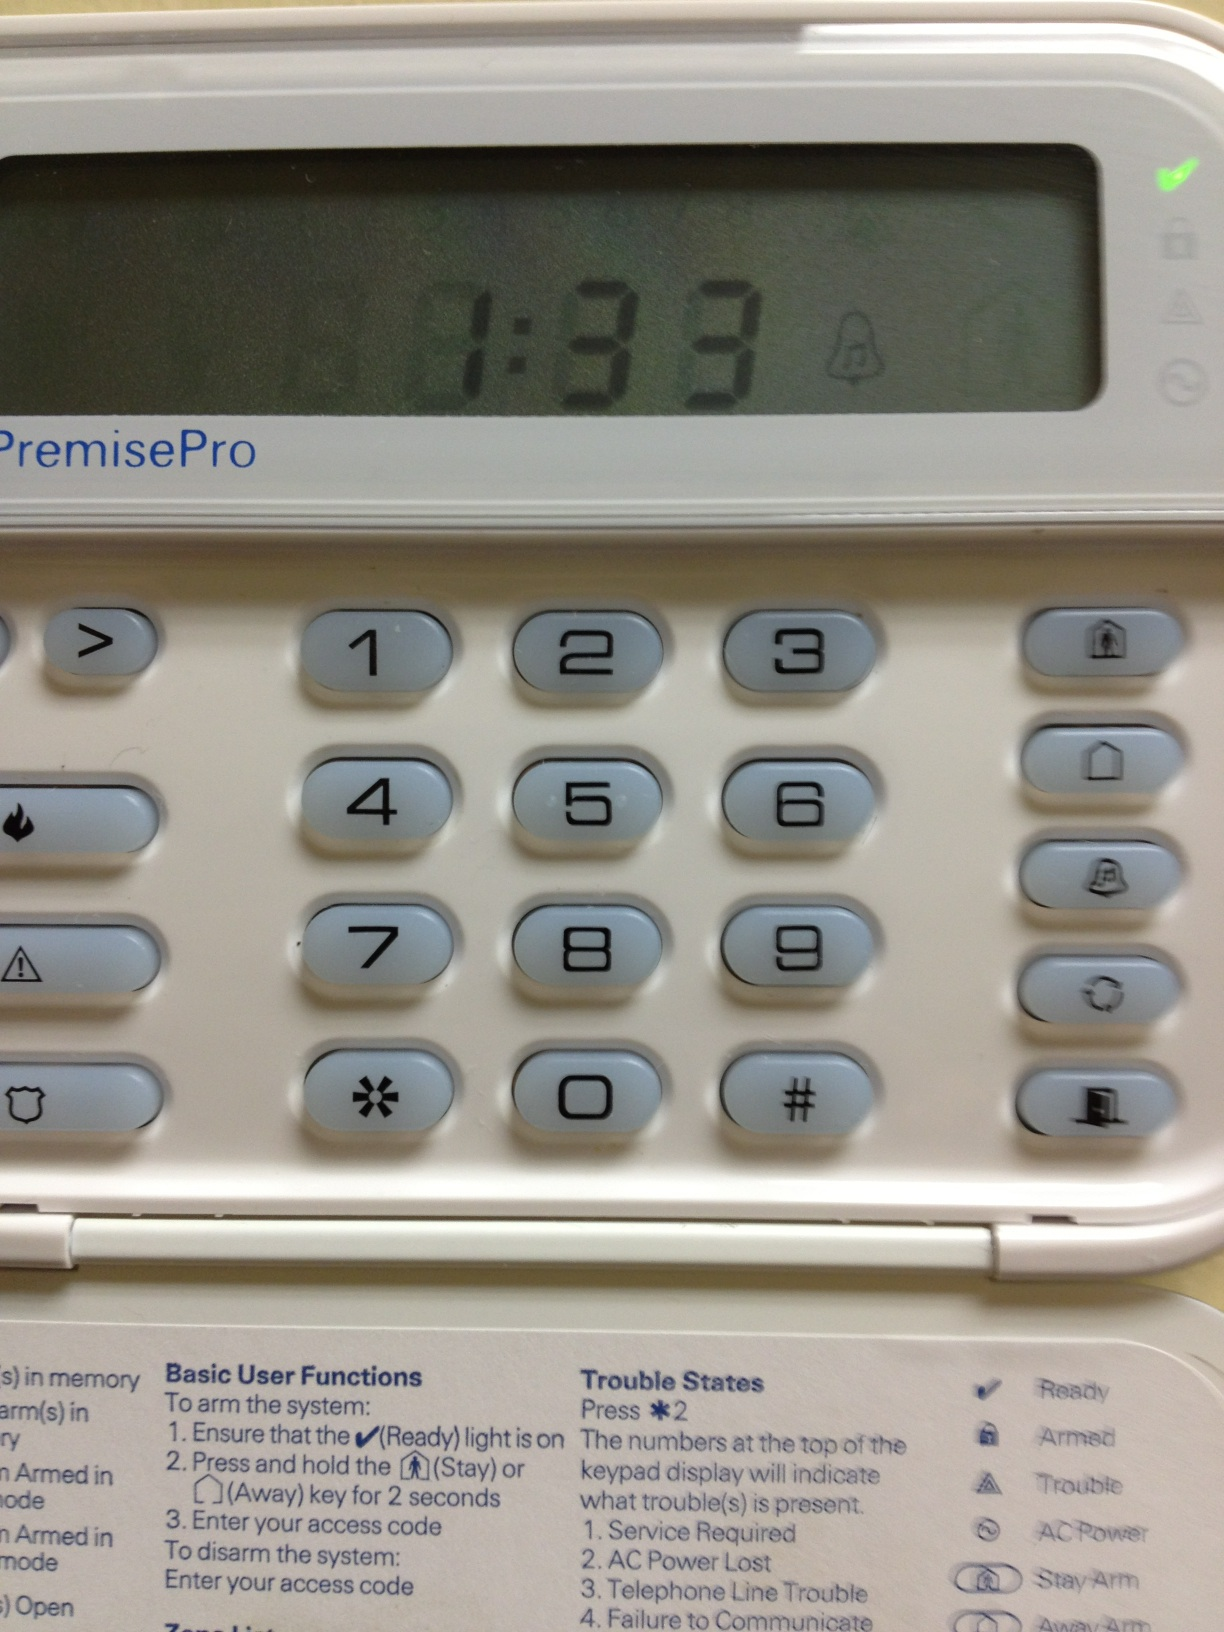Can you explain what the 'Trouble States' on this keypad mean? The 'Trouble States' indicates various issues that require attention. For instance, 'Service Required' suggests the system needs maintenance, 'AC Power Lost' signals a power interruption, 'Telephone Line Trouble' implies communication issues, and 'Failure to Communicate' indicates the system is unable to send signals, possibly to a monitoring service. 